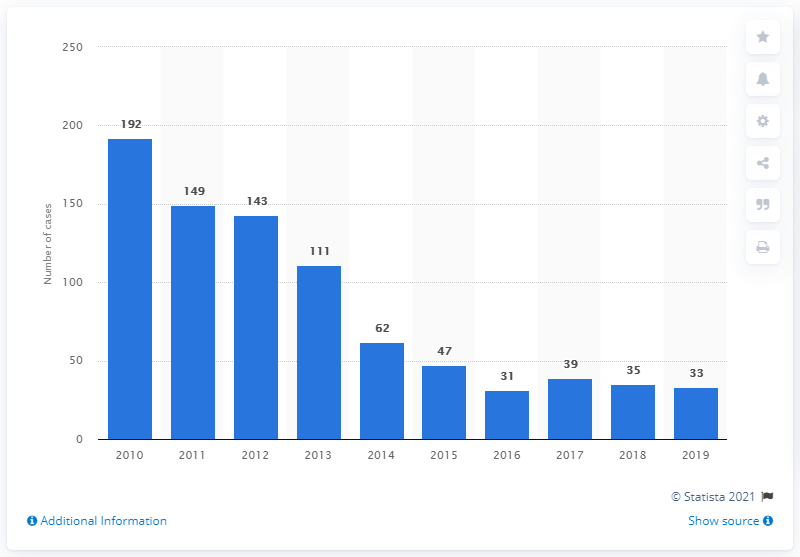Compared to surrounding years, what stands out about the data for 2016? The bar graph shows a significant decrease in malaria cases for 2016, dropping to 31 from 47 in 2015. This could indicate an especially effective year for malaria prevention or other factors such as climate conditions that may have contributed to the reduction. 